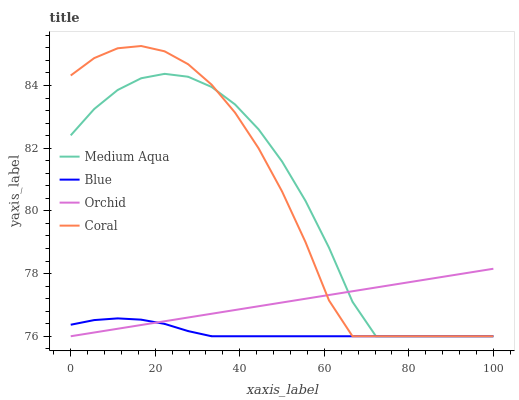Does Blue have the minimum area under the curve?
Answer yes or no. Yes. Does Coral have the maximum area under the curve?
Answer yes or no. Yes. Does Medium Aqua have the minimum area under the curve?
Answer yes or no. No. Does Medium Aqua have the maximum area under the curve?
Answer yes or no. No. Is Orchid the smoothest?
Answer yes or no. Yes. Is Medium Aqua the roughest?
Answer yes or no. Yes. Is Coral the smoothest?
Answer yes or no. No. Is Coral the roughest?
Answer yes or no. No. Does Blue have the lowest value?
Answer yes or no. Yes. Does Coral have the highest value?
Answer yes or no. Yes. Does Medium Aqua have the highest value?
Answer yes or no. No. Does Medium Aqua intersect Orchid?
Answer yes or no. Yes. Is Medium Aqua less than Orchid?
Answer yes or no. No. Is Medium Aqua greater than Orchid?
Answer yes or no. No. 